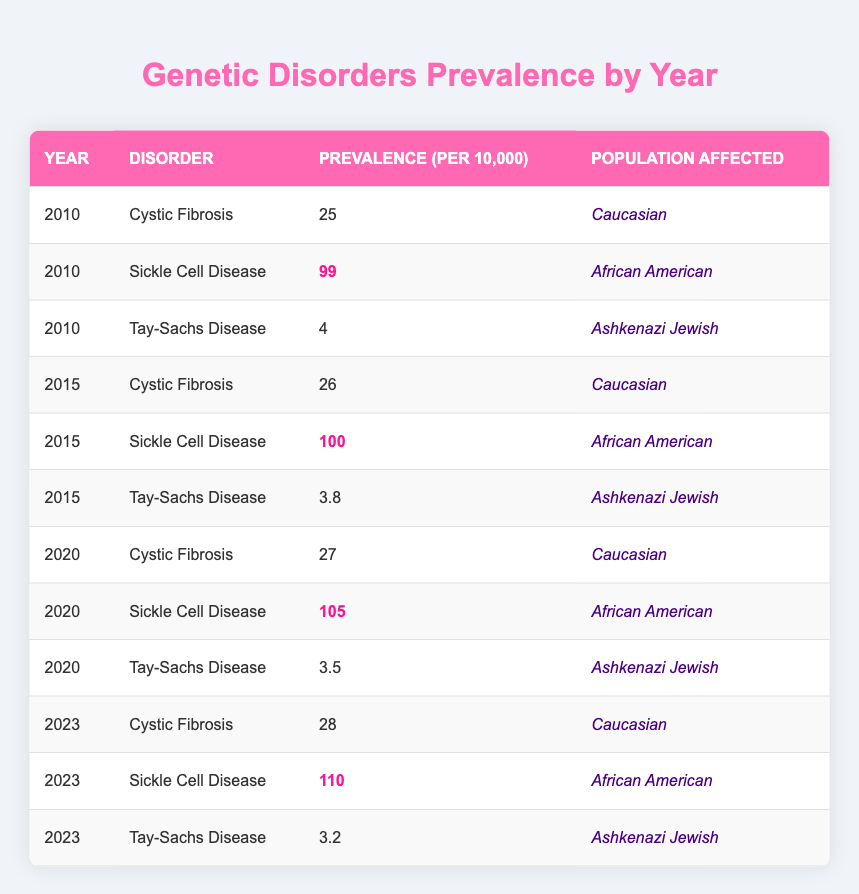What is the prevalence of Sickle Cell Disease in 2023? In the table, find the row for the year 2023 and the disorder Sickle Cell Disease. The prevalence for this row is highlighted and shows a value of 110.
Answer: 110 How did the prevalence of Cystic Fibrosis change from 2010 to 2023? Look at the prevalence of Cystic Fibrosis for both years. In 2010, it was 25, and in 2023, it is 28. The change from 25 to 28 indicates an increase of 3.
Answer: Increased by 3 What is the highest prevalence of Tay-Sachs Disease recorded in the table? To find the highest prevalence, compare the values for Tay-Sachs Disease across all years listed. The values are 4, 3.8, 3.5, and 3.2. The highest value is 4 from 2010.
Answer: 4 What was the prevalence of Sickle Cell Disease in 2010 compared to 2020? For 2010, the prevalence is 99, and for 2020, it is 105. Since 105 is greater than 99, this indicates an increase over the 10 year period.
Answer: Increased Is the prevalence of Tay-Sachs Disease higher in 2010 or 2023? Look at the prevalence values for Tay-Sachs Disease in both years. In 2010, it was 4, and in 2023, it is 3.2. Since 4 is greater than 3.2, it was higher in 2010.
Answer: 2010 What is the average prevalence of Cystic Fibrosis from 2010 to 2023? The values for Cystic Fibrosis are 25, 26, 27, and 28. To find the average, sum these values (25 + 26 + 27 + 28 = 106) and then divide by 4 (the number of years). Thus, 106 / 4 = 26.5.
Answer: 26.5 Which disorder had the lowest prevalence in 2015? Look at the prevalence values for each disorder in 2015: Cystic Fibrosis (26), Sickle Cell Disease (100), and Tay-Sachs Disease (3.8). Tay-Sachs has the lowest value of 3.8.
Answer: Tay-Sachs Disease If we compare the Sickle Cell Disease prevalence in 2020 and 2023, what is the difference? From the table, Sickle Cell Disease has a prevalence of 105 in 2020 and 110 in 2023. Subtract 105 from 110 to find the difference, which is 5.
Answer: 5 Is the prevalence of Sickle Cell Disease consistently increasing from 2010 to 2023? Check the prevalence for each year: 99 (2010), 100 (2015), 105 (2020), and 110 (2023). Each subsequent year shows higher prevalence compared to the previous year, indicating consistent increase.
Answer: Yes What population group is most affected by Cystic Fibrosis? The table indicates that Cystic Fibrosis affects the Caucasian population. This is consistent across all years listed in the table.
Answer: Caucasian What is the percentage increase in the prevalence of Sickle Cell Disease from 2010 to 2023? The prevalence rose from 99 in 2010 to 110 in 2023. The increase is 110 - 99 = 11. The percentage increase is (11 / 99) * 100, which is approximately 11.11%.
Answer: 11.11% 